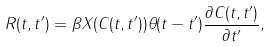<formula> <loc_0><loc_0><loc_500><loc_500>R ( t , t ^ { \prime } ) = \beta X ( C ( t , t ^ { \prime } ) ) \theta ( t - t ^ { \prime } ) \frac { \partial C ( t , t ^ { \prime } ) } { \partial t ^ { \prime } } ,</formula> 